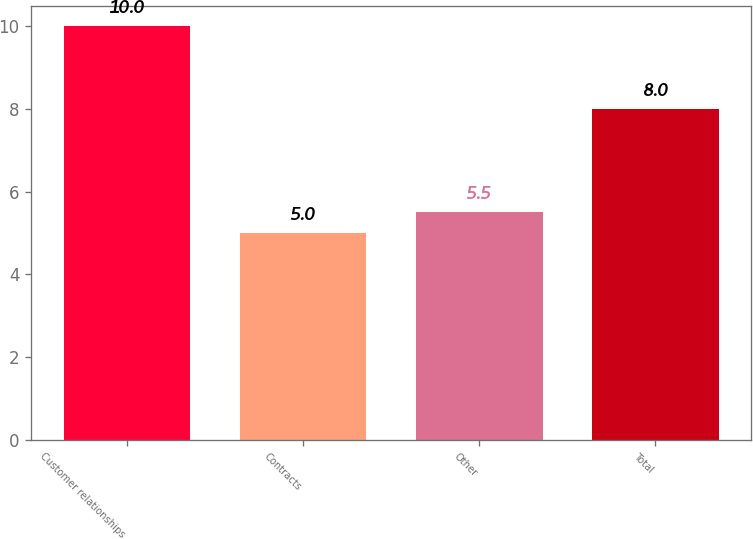Convert chart. <chart><loc_0><loc_0><loc_500><loc_500><bar_chart><fcel>Customer relationships<fcel>Contracts<fcel>Other<fcel>Total<nl><fcel>10<fcel>5<fcel>5.5<fcel>8<nl></chart> 